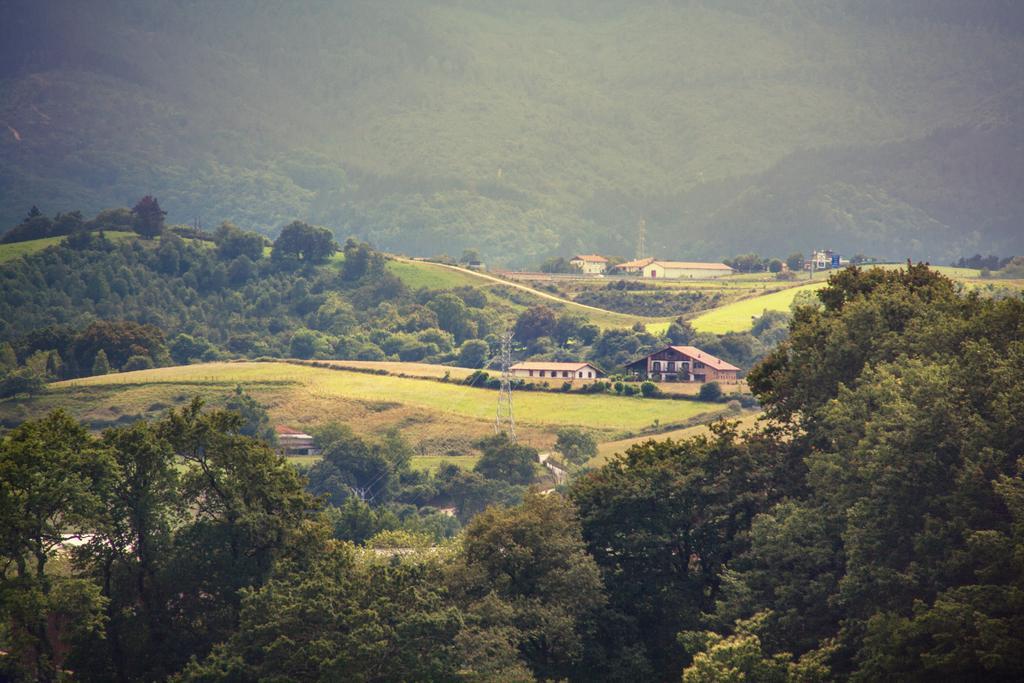Describe this image in one or two sentences. This picture shows trees and few buildings. 